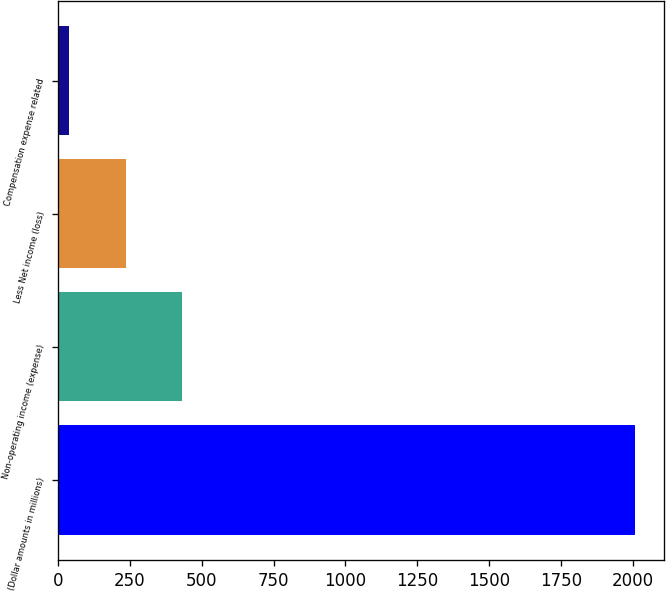<chart> <loc_0><loc_0><loc_500><loc_500><bar_chart><fcel>(Dollar amounts in millions)<fcel>Non-operating income (expense)<fcel>Less Net income (loss)<fcel>Compensation expense related<nl><fcel>2008<fcel>432<fcel>235<fcel>38<nl></chart> 